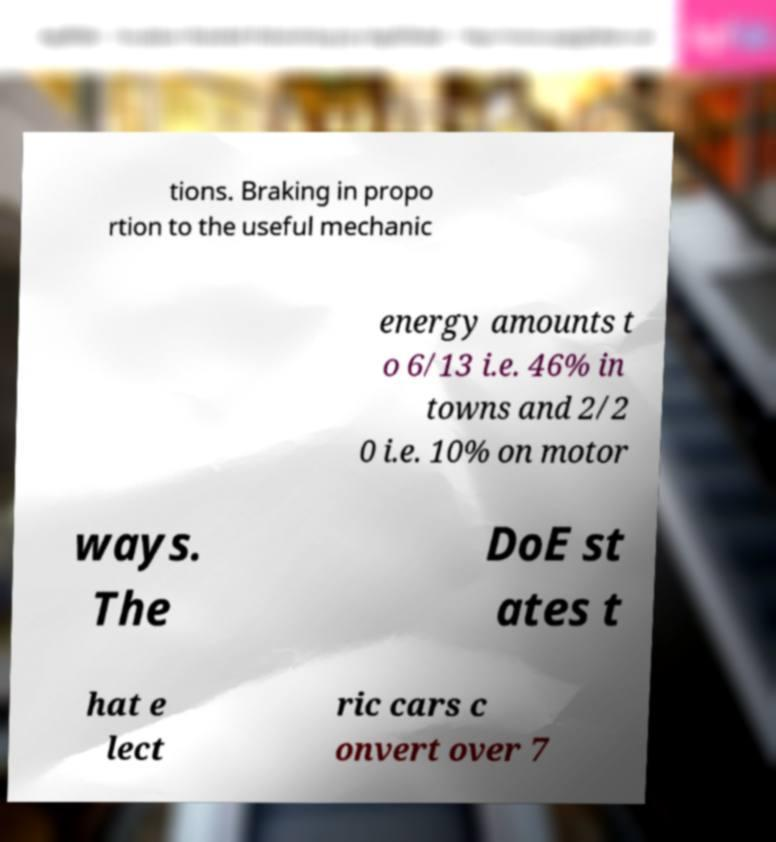Can you accurately transcribe the text from the provided image for me? tions. Braking in propo rtion to the useful mechanic energy amounts t o 6/13 i.e. 46% in towns and 2/2 0 i.e. 10% on motor ways. The DoE st ates t hat e lect ric cars c onvert over 7 